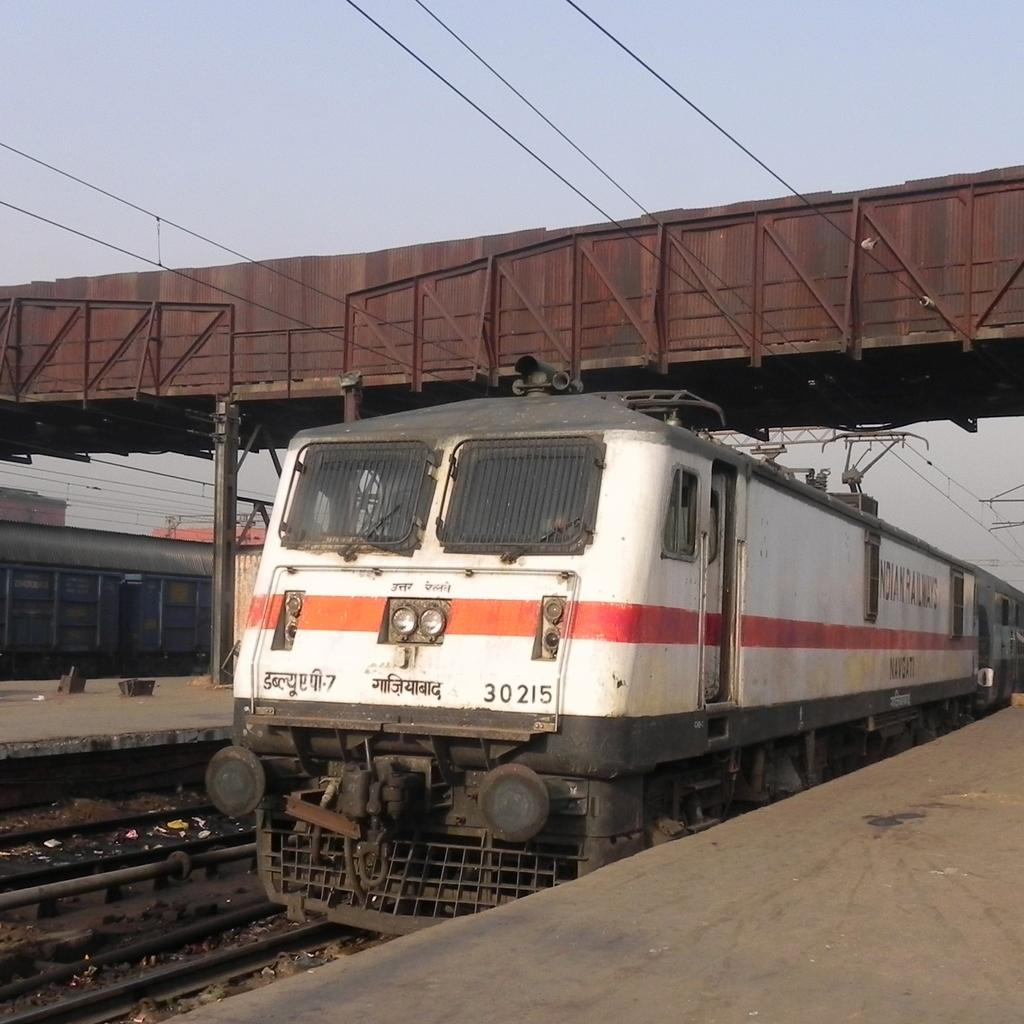<image>
Offer a succinct explanation of the picture presented. A white locomotive with a red stripe with the number 30215 on the front waits at a platform. 